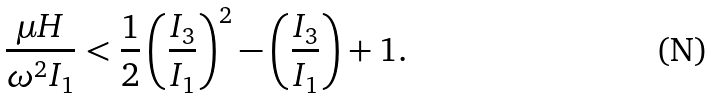<formula> <loc_0><loc_0><loc_500><loc_500>\frac { \mu H } { \omega ^ { 2 } I _ { 1 } } < \frac { 1 } { 2 } \left ( \frac { I _ { 3 } } { I _ { 1 } } \right ) ^ { 2 } - \left ( \frac { I _ { 3 } } { I _ { 1 } } \right ) + 1 .</formula> 